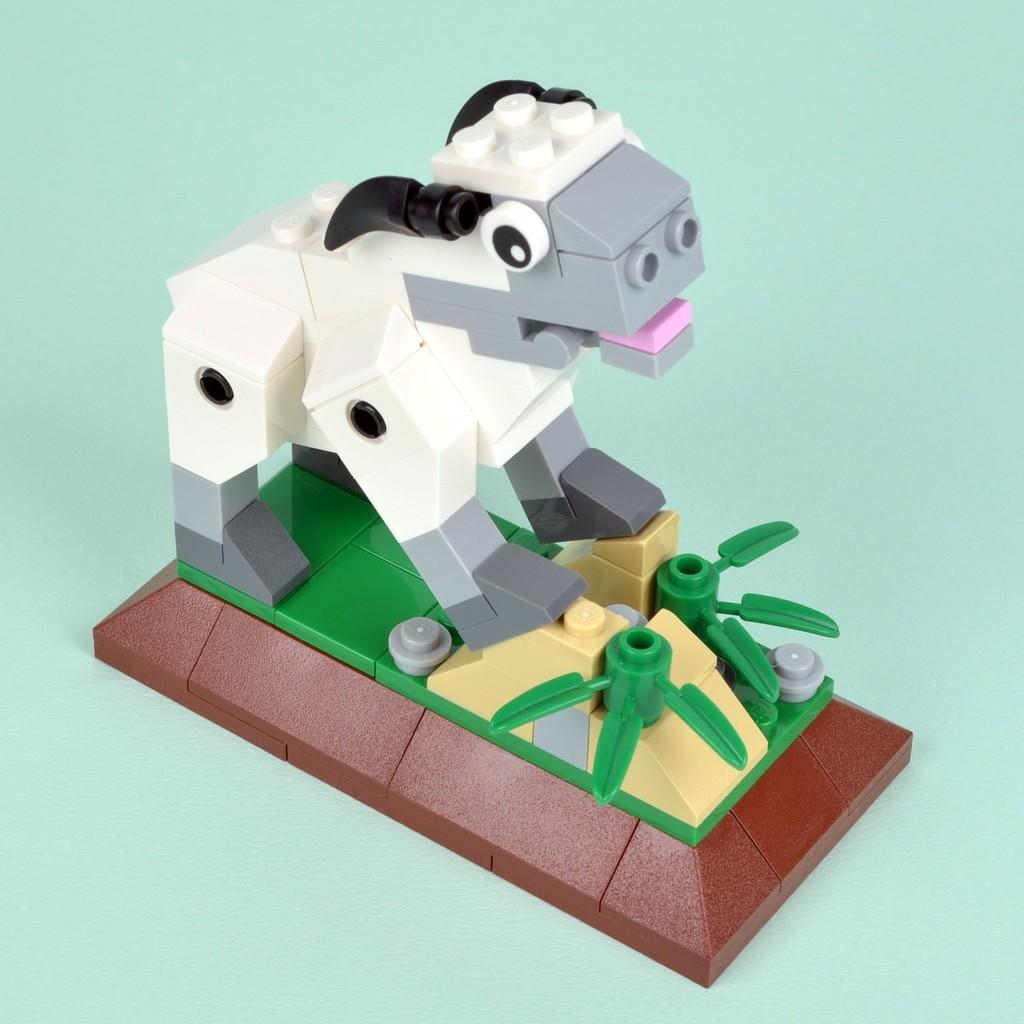What type of creature is present in the image? There is an animal in the image. Where is the animal located in the image? The animal is standing on a platform. What can be seen on the platform besides the animal? There are objects made with Lego toys on the platform. Is there a woman holding a can near the coast in the image? There is no woman, can, or coast present in the image. 